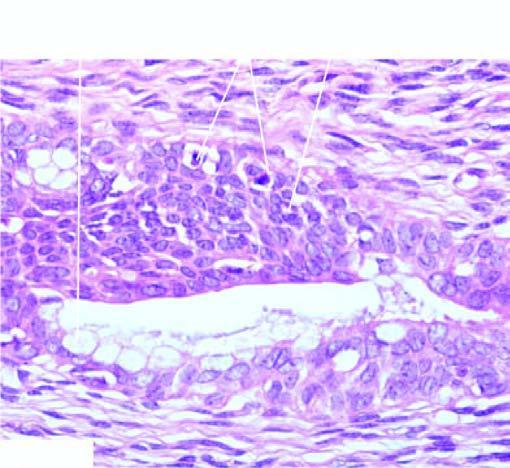what have marked cytologic atypia including mitoses?
Answer the question using a single word or phrase. Layers of squamous epithelium 